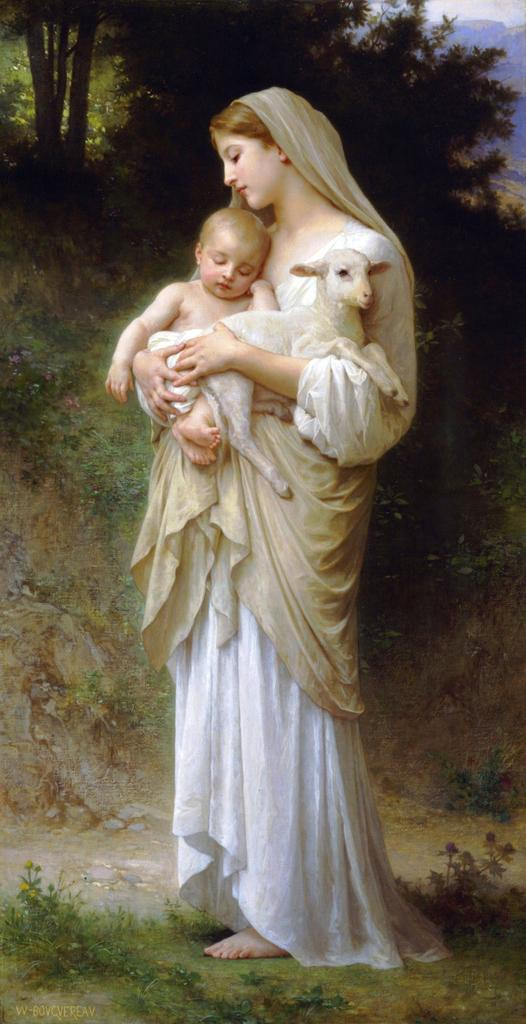What is the main subject of the painting in the image? The painting depicts a woman standing and carrying a baby and a goat. What other elements can be seen in the painting? There are plants and trees in the image. How much dust can be seen on the painting in the image? There is no information about dust on the painting in the provided facts, so it cannot be determined from the image. 